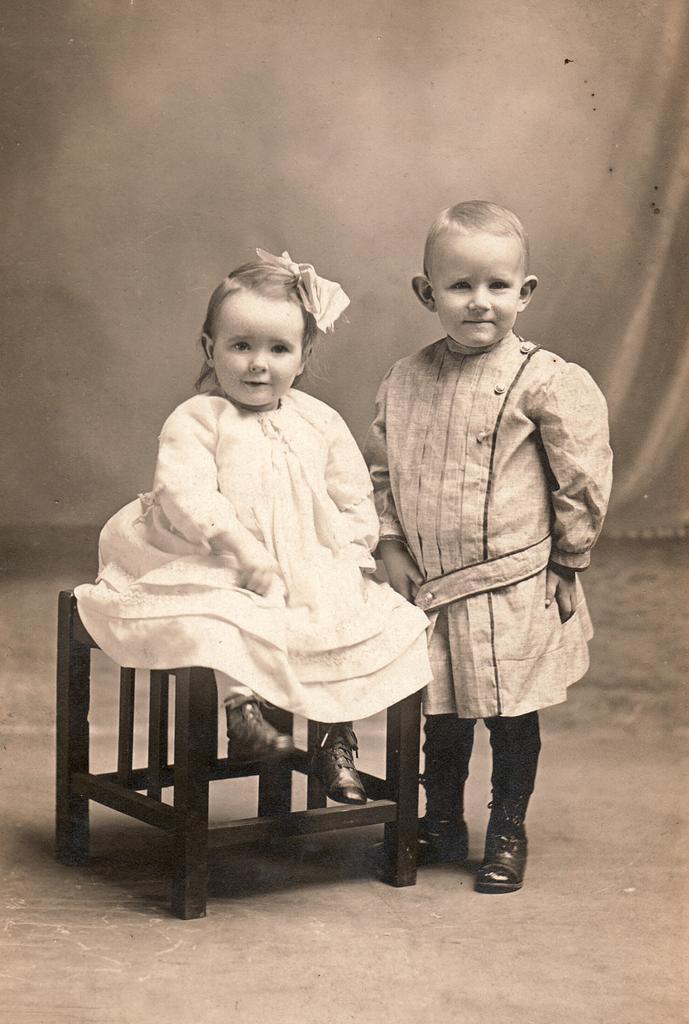How would you summarize this image in a sentence or two? In this black and white image, there is a small girl and a boy in the foreground. 